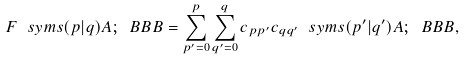<formula> <loc_0><loc_0><loc_500><loc_500>F \ s y m s { ( p | q ) } { \AA A ; \ B B B } = \sum _ { p ^ { \prime } = 0 } ^ { p } \sum _ { q ^ { \prime } = 0 } ^ { q } c _ { p p ^ { \prime } } c _ { q q ^ { \prime } } \ s y m s { ( p ^ { \prime } | q ^ { \prime } ) } { \AA A ; \ B B B } ,</formula> 